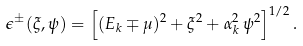Convert formula to latex. <formula><loc_0><loc_0><loc_500><loc_500>\epsilon ^ { \pm } ( \xi , \psi ) = \left [ ( E _ { k } \mp \mu ) ^ { 2 } + \xi ^ { 2 } + \alpha _ { k } ^ { 2 } \, \psi ^ { 2 } \right ] ^ { 1 / 2 } .</formula> 